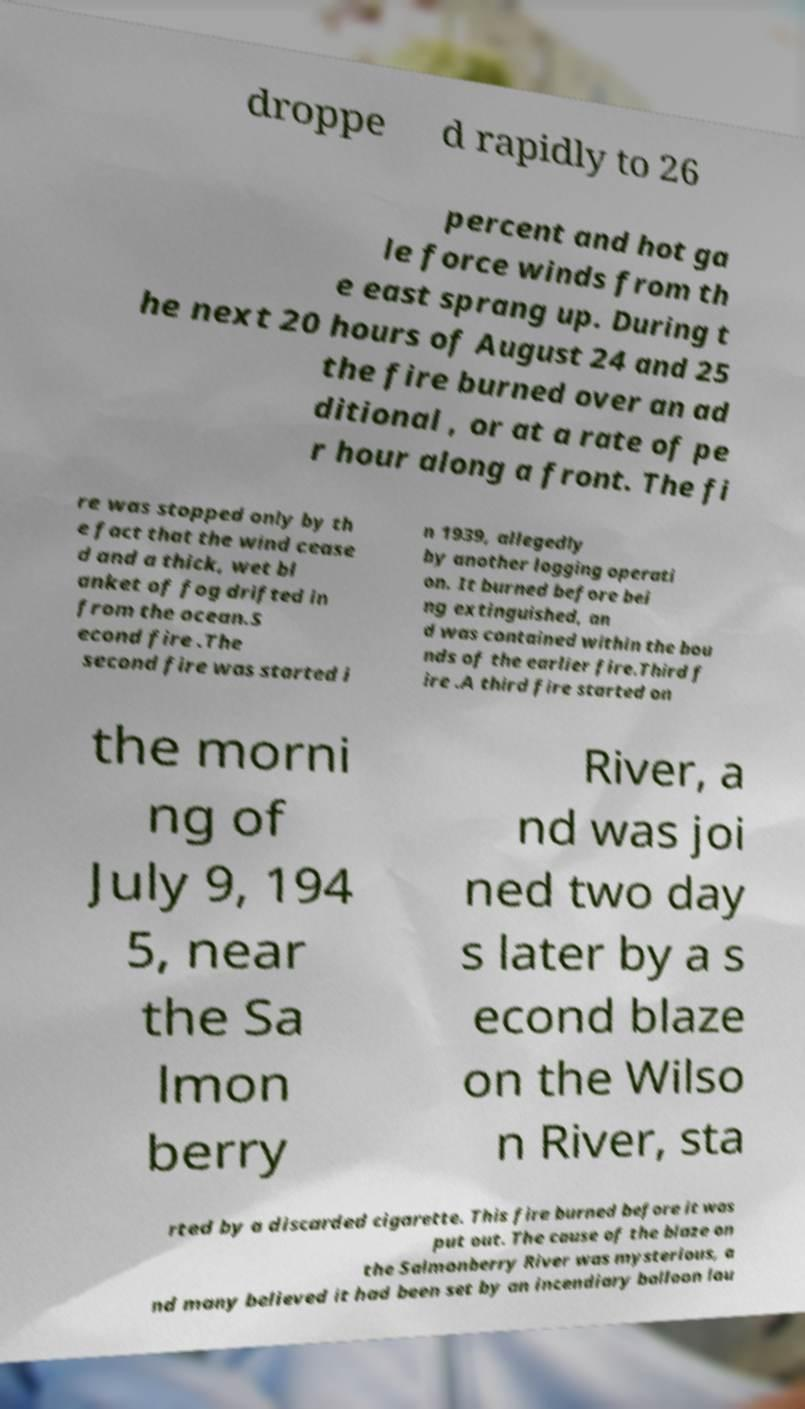Could you extract and type out the text from this image? droppe d rapidly to 26 percent and hot ga le force winds from th e east sprang up. During t he next 20 hours of August 24 and 25 the fire burned over an ad ditional , or at a rate of pe r hour along a front. The fi re was stopped only by th e fact that the wind cease d and a thick, wet bl anket of fog drifted in from the ocean.S econd fire .The second fire was started i n 1939, allegedly by another logging operati on. It burned before bei ng extinguished, an d was contained within the bou nds of the earlier fire.Third f ire .A third fire started on the morni ng of July 9, 194 5, near the Sa lmon berry River, a nd was joi ned two day s later by a s econd blaze on the Wilso n River, sta rted by a discarded cigarette. This fire burned before it was put out. The cause of the blaze on the Salmonberry River was mysterious, a nd many believed it had been set by an incendiary balloon lau 